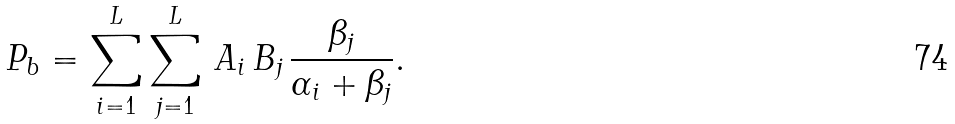<formula> <loc_0><loc_0><loc_500><loc_500>P _ { b } = \sum _ { i = 1 } ^ { L } \sum _ { j = 1 } ^ { L } \, A _ { i } \, B _ { j } \, \frac { \beta _ { j } } { \alpha _ { i } + \beta _ { j } } .</formula> 